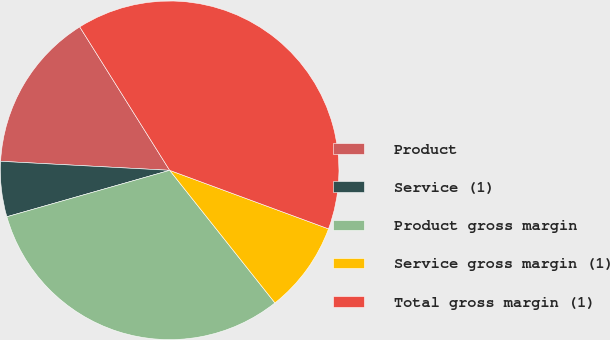Convert chart to OTSL. <chart><loc_0><loc_0><loc_500><loc_500><pie_chart><fcel>Product<fcel>Service (1)<fcel>Product gross margin<fcel>Service gross margin (1)<fcel>Total gross margin (1)<nl><fcel>15.24%<fcel>5.27%<fcel>31.26%<fcel>8.7%<fcel>39.53%<nl></chart> 